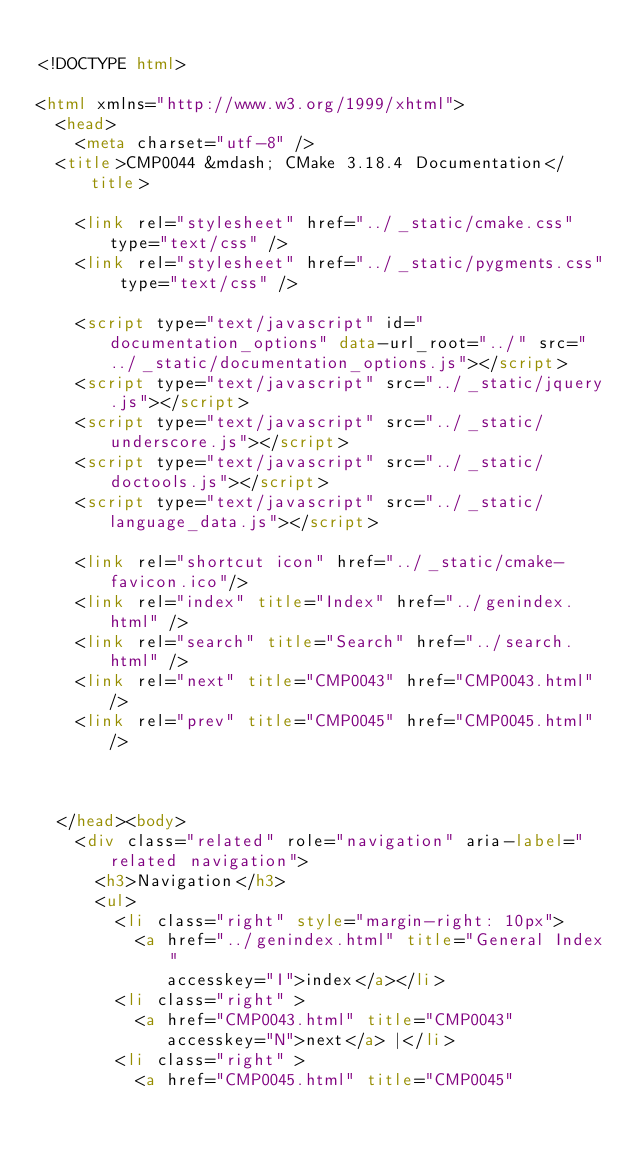Convert code to text. <code><loc_0><loc_0><loc_500><loc_500><_HTML_>
<!DOCTYPE html>

<html xmlns="http://www.w3.org/1999/xhtml">
  <head>
    <meta charset="utf-8" />
  <title>CMP0044 &mdash; CMake 3.18.4 Documentation</title>

    <link rel="stylesheet" href="../_static/cmake.css" type="text/css" />
    <link rel="stylesheet" href="../_static/pygments.css" type="text/css" />
    
    <script type="text/javascript" id="documentation_options" data-url_root="../" src="../_static/documentation_options.js"></script>
    <script type="text/javascript" src="../_static/jquery.js"></script>
    <script type="text/javascript" src="../_static/underscore.js"></script>
    <script type="text/javascript" src="../_static/doctools.js"></script>
    <script type="text/javascript" src="../_static/language_data.js"></script>
    
    <link rel="shortcut icon" href="../_static/cmake-favicon.ico"/>
    <link rel="index" title="Index" href="../genindex.html" />
    <link rel="search" title="Search" href="../search.html" />
    <link rel="next" title="CMP0043" href="CMP0043.html" />
    <link rel="prev" title="CMP0045" href="CMP0045.html" />
  
 

  </head><body>
    <div class="related" role="navigation" aria-label="related navigation">
      <h3>Navigation</h3>
      <ul>
        <li class="right" style="margin-right: 10px">
          <a href="../genindex.html" title="General Index"
             accesskey="I">index</a></li>
        <li class="right" >
          <a href="CMP0043.html" title="CMP0043"
             accesskey="N">next</a> |</li>
        <li class="right" >
          <a href="CMP0045.html" title="CMP0045"</code> 